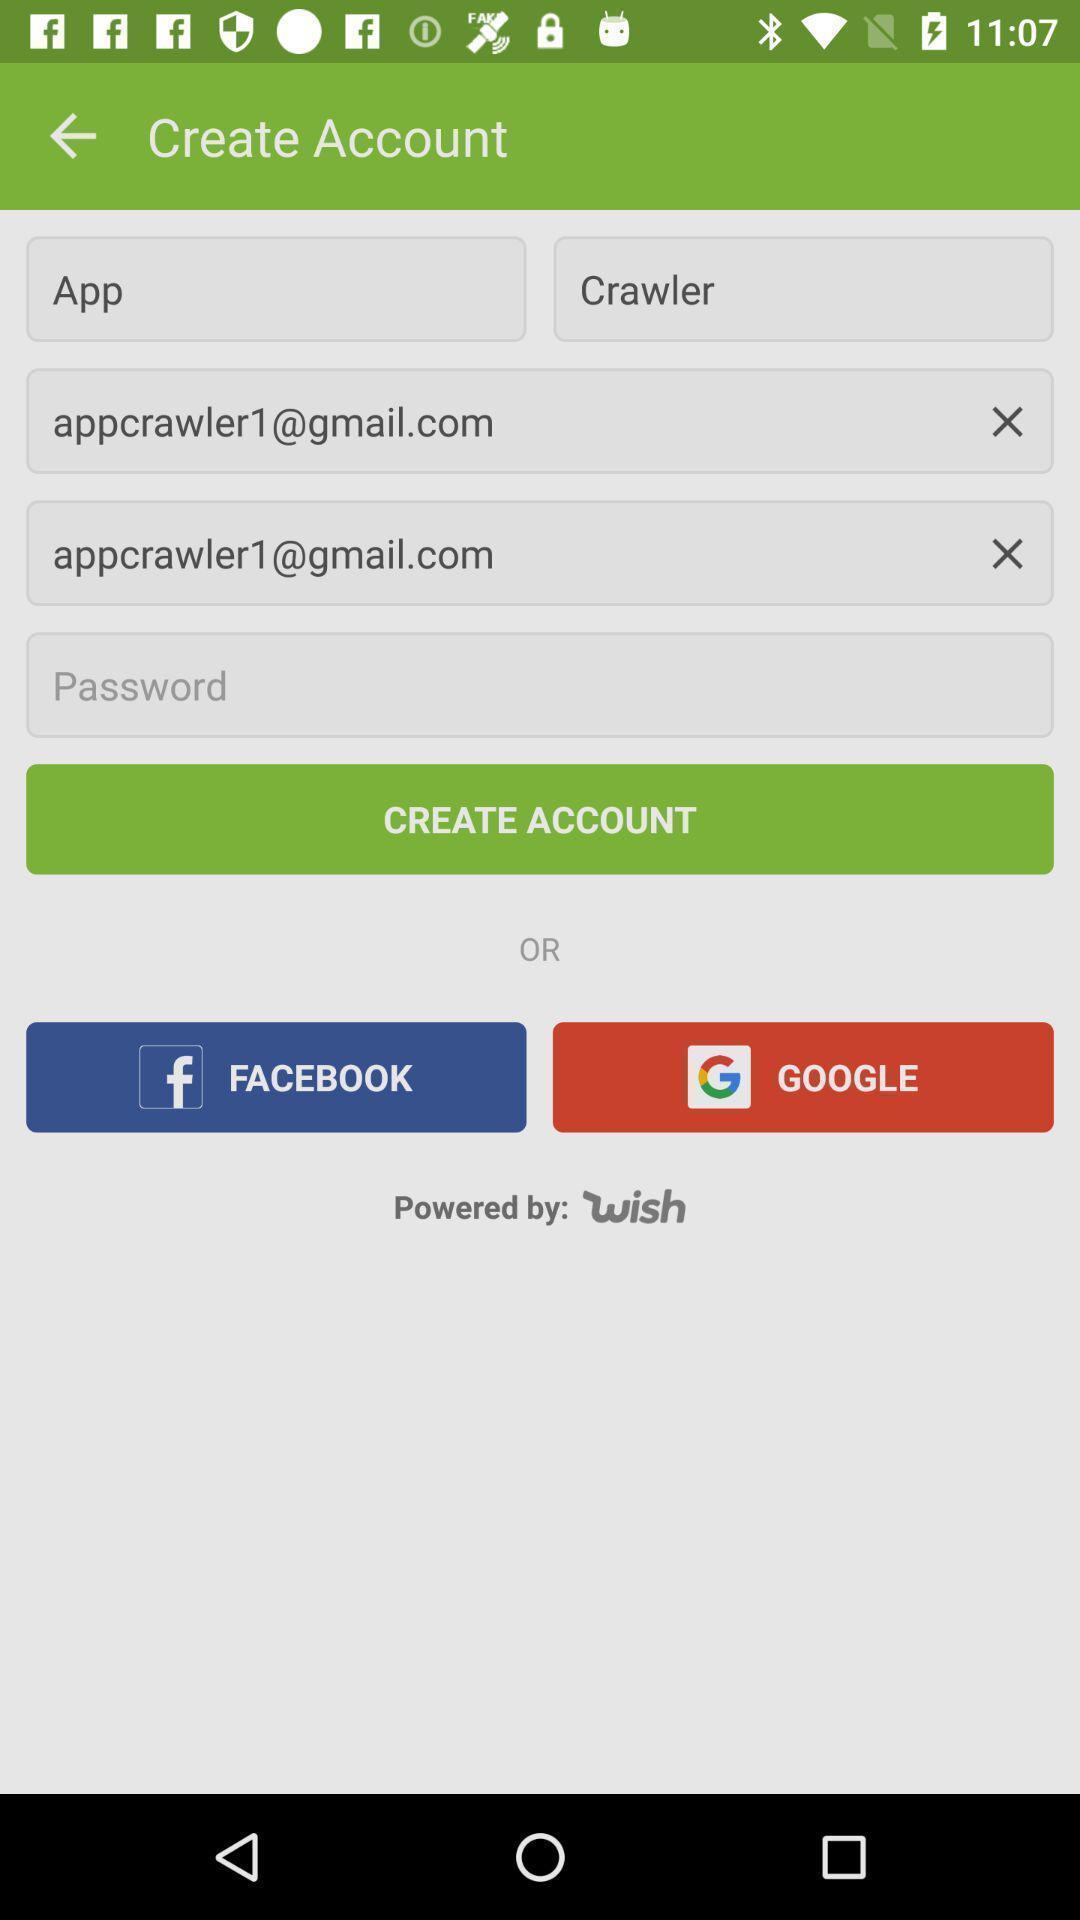Describe the key features of this screenshot. Screen showing create account page of shopping app. 